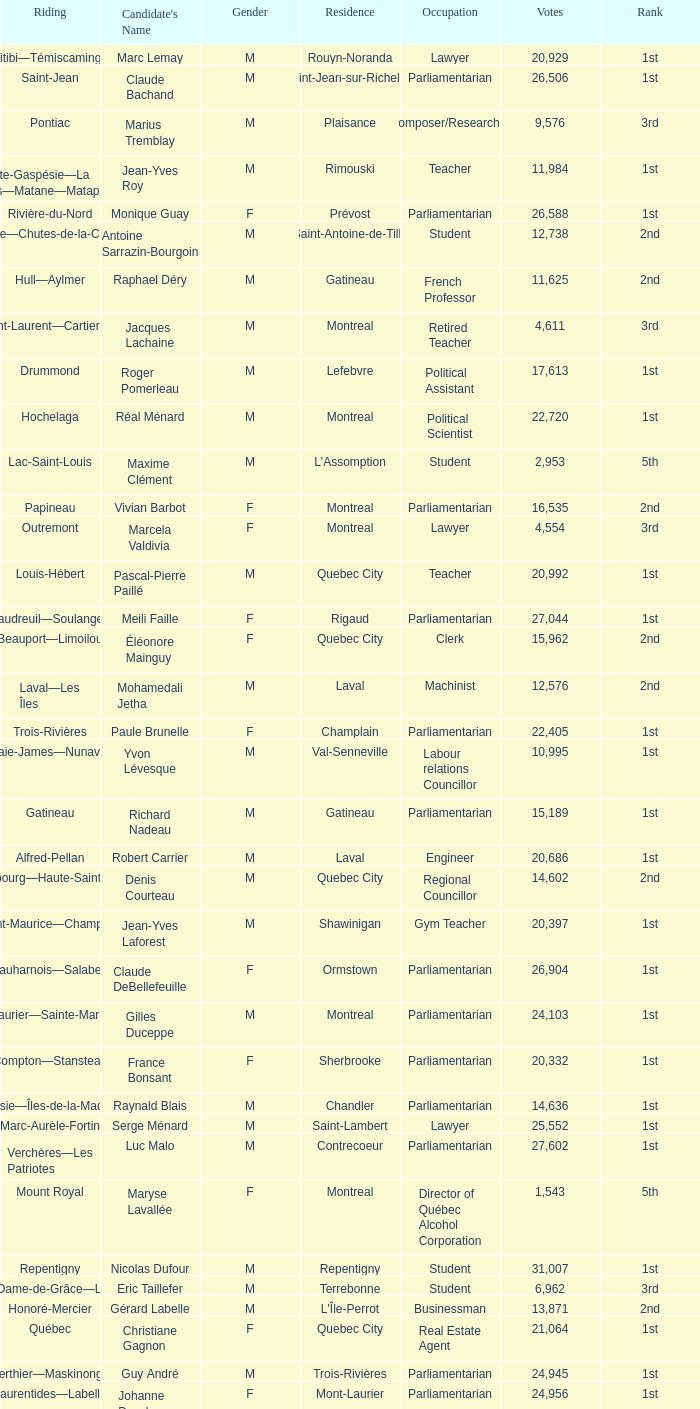What is the highest number of votes for the French Professor? 11625.0. 